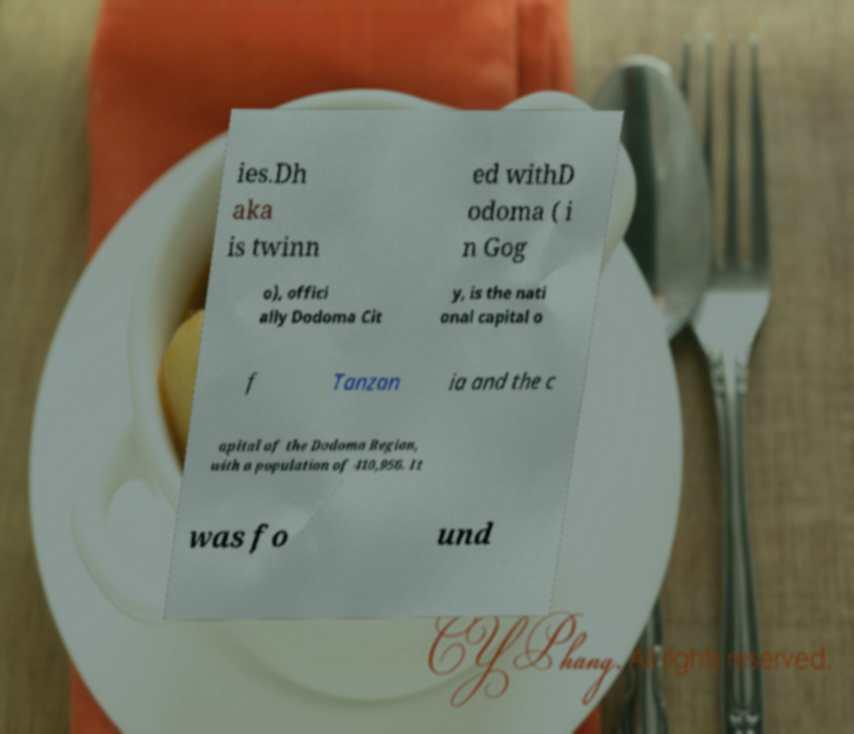Can you read and provide the text displayed in the image?This photo seems to have some interesting text. Can you extract and type it out for me? ies.Dh aka is twinn ed withD odoma ( i n Gog o), offici ally Dodoma Cit y, is the nati onal capital o f Tanzan ia and the c apital of the Dodoma Region, with a population of 410,956. It was fo und 